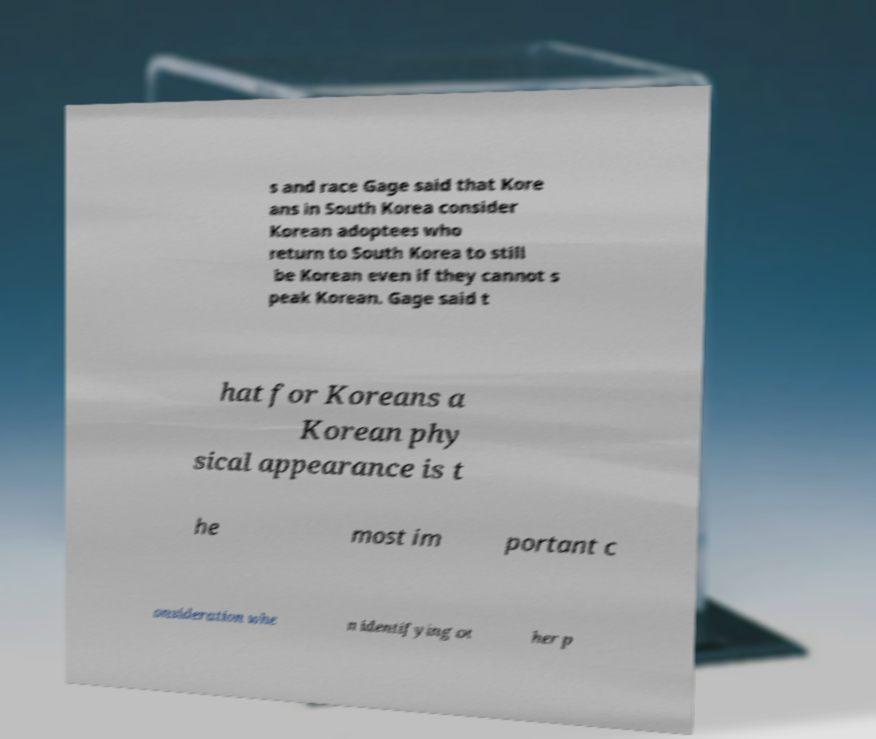Please read and relay the text visible in this image. What does it say? s and race Gage said that Kore ans in South Korea consider Korean adoptees who return to South Korea to still be Korean even if they cannot s peak Korean. Gage said t hat for Koreans a Korean phy sical appearance is t he most im portant c onsideration whe n identifying ot her p 